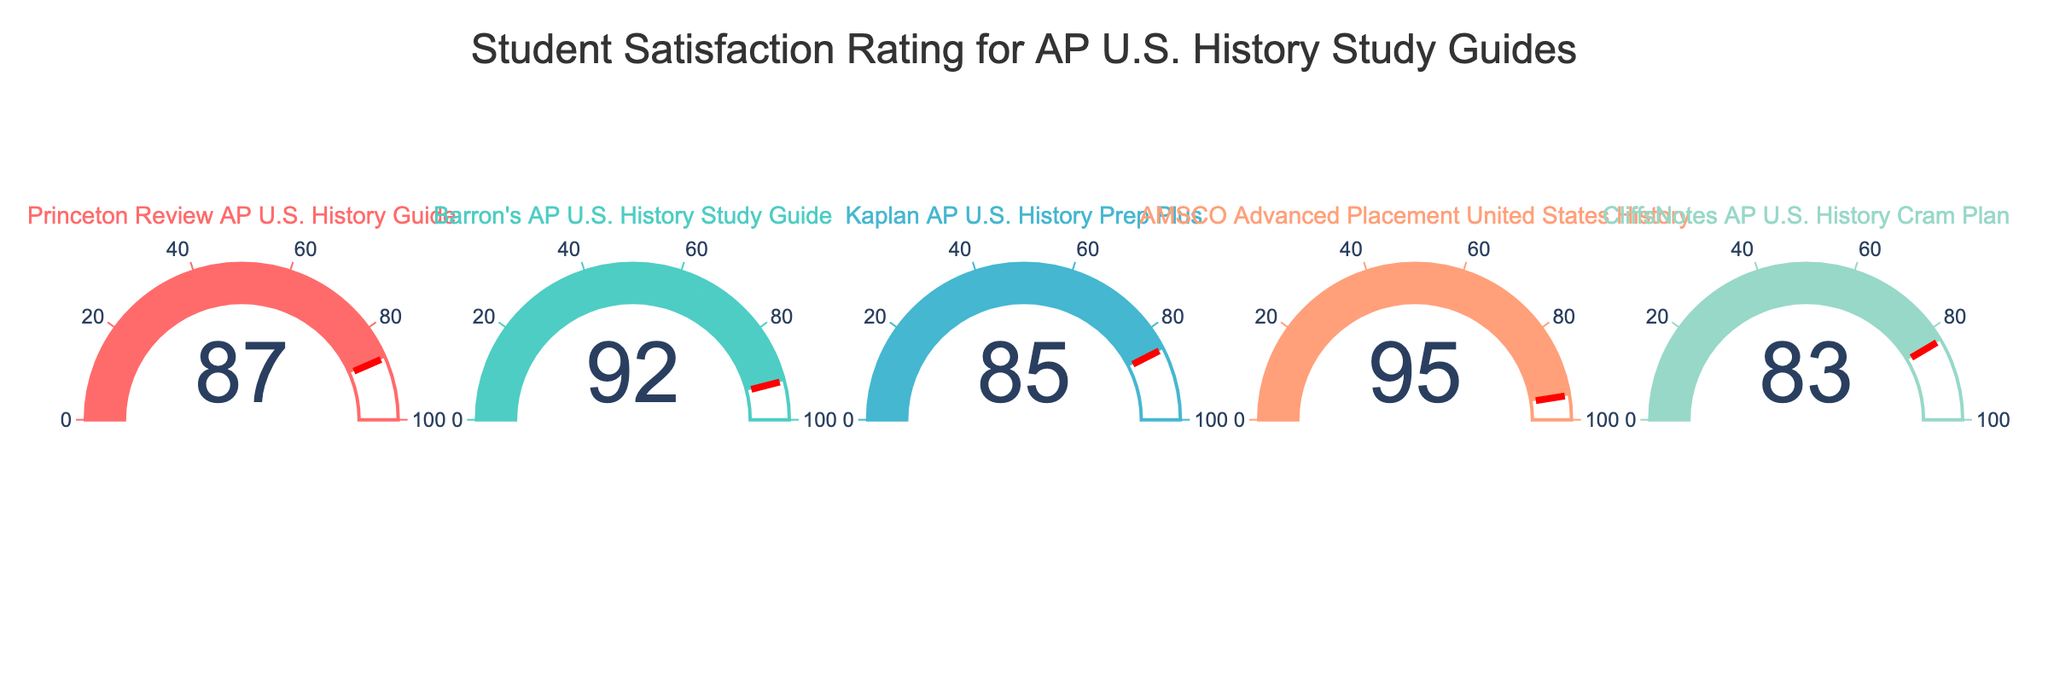What is the satisfaction rating for the Princeton Review AP U.S. History Guide? The figure shows a gauge indicating the satisfaction rating for the Princeton Review AP U.S. History Guide. Just look at the number displayed on the gauge.
Answer: 87 How many study guides have a satisfaction rating above 90? Observing the figure, count the number of study guides with values greater than 90 on their gauges.
Answer: 2 Which study guide received the lowest satisfaction rating? Compare the values displayed on each gauge to determine the lowest rating.
Answer: CliffsNotes AP U.S. History Cram Plan What is the average satisfaction rating across all study guides? Sum the satisfaction ratings for all study guides and divide by the number of guides. (87 + 92 + 85 + 95 + 83) / 5 = 88.4
Answer: 88.4 How much higher is the satisfaction rating of AMSCO Advanced Placement United States History compared to Kaplan AP U.S. History Prep Plus? Subtract the satisfaction rating of Kaplan AP U.S. History Prep Plus from AMSCO Advanced Placement United States History. 95 - 85 = 10
Answer: 10 What is the median satisfaction rating among the study guides? Sort the satisfaction ratings (83, 85, 87, 92, 95) and identify the middle value.
Answer: 87 Which study guide has the closest satisfaction rating to the median value? Find the satisfaction rating that is nearest to the median value of 87.
Answer: Princeton Review AP U.S. History Guide Are there any study guides with an equal or lower satisfaction rating than the Princeton Review AP U.S. History Guide? Compare the satisfaction ratings with that of Princeton Review (87) to see if any are equal to or less than it.
Answer: Yes, CliffsNotes AP U.S. History Cram Plan, Kaplan AP U.S. History Prep Plus 